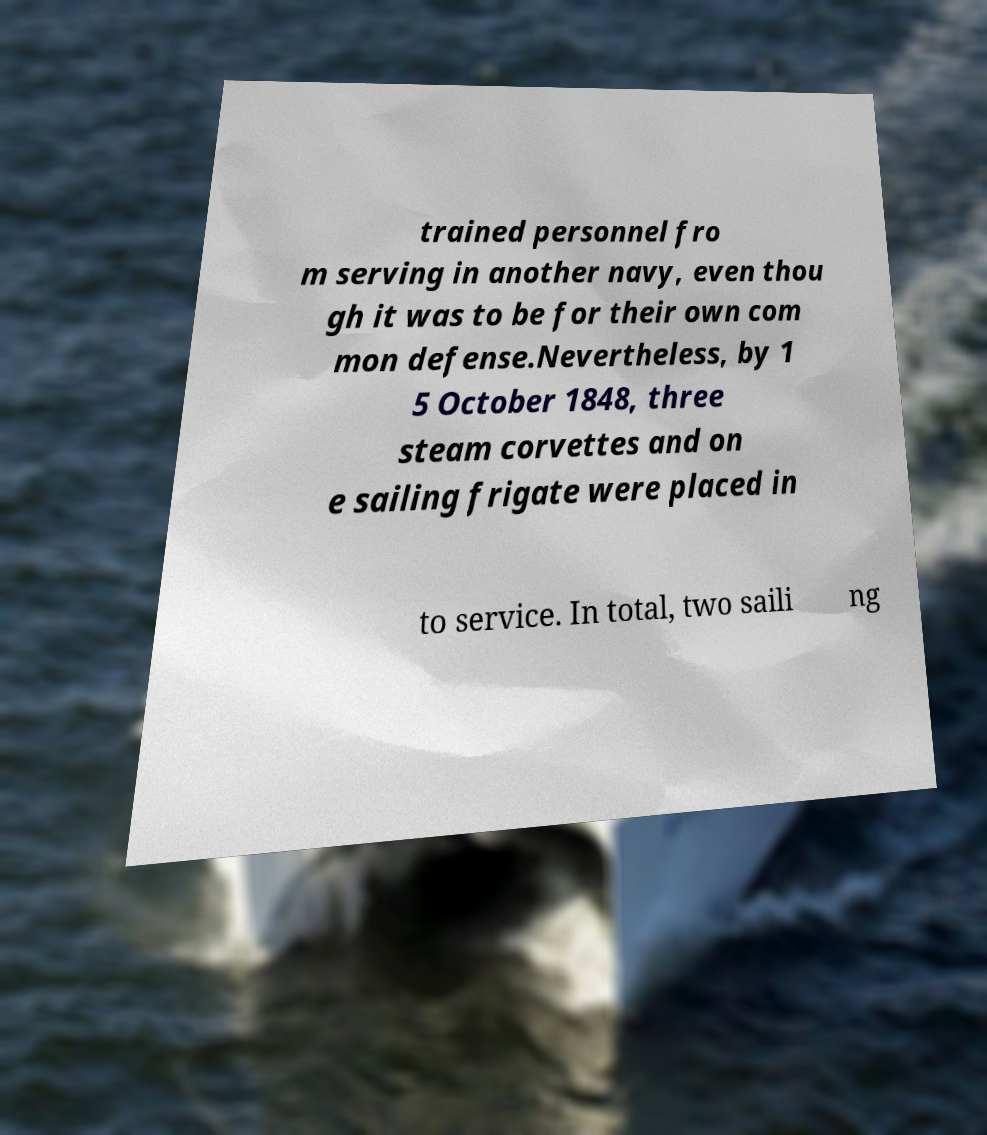There's text embedded in this image that I need extracted. Can you transcribe it verbatim? trained personnel fro m serving in another navy, even thou gh it was to be for their own com mon defense.Nevertheless, by 1 5 October 1848, three steam corvettes and on e sailing frigate were placed in to service. In total, two saili ng 